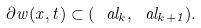<formula> <loc_0><loc_0><loc_500><loc_500>\partial w ( x , t ) \subset ( \ a l _ { k } , \ a l _ { k + 1 } ) .</formula> 